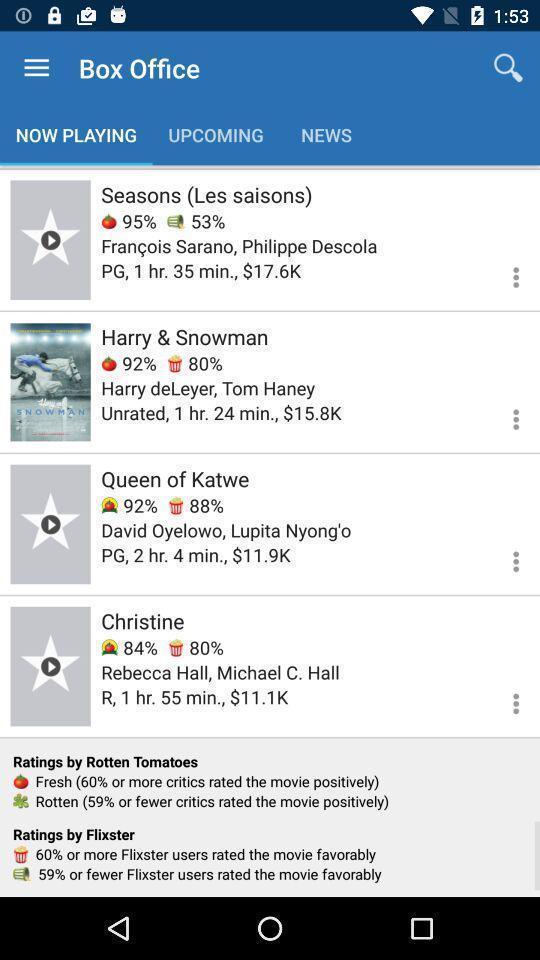Explain the elements present in this screenshot. Screen shows playing list. 